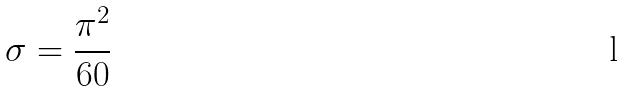Convert formula to latex. <formula><loc_0><loc_0><loc_500><loc_500>\sigma = \frac { \pi ^ { 2 } } { 6 0 }</formula> 